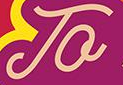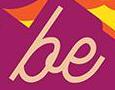Transcribe the words shown in these images in order, separated by a semicolon. To; be 